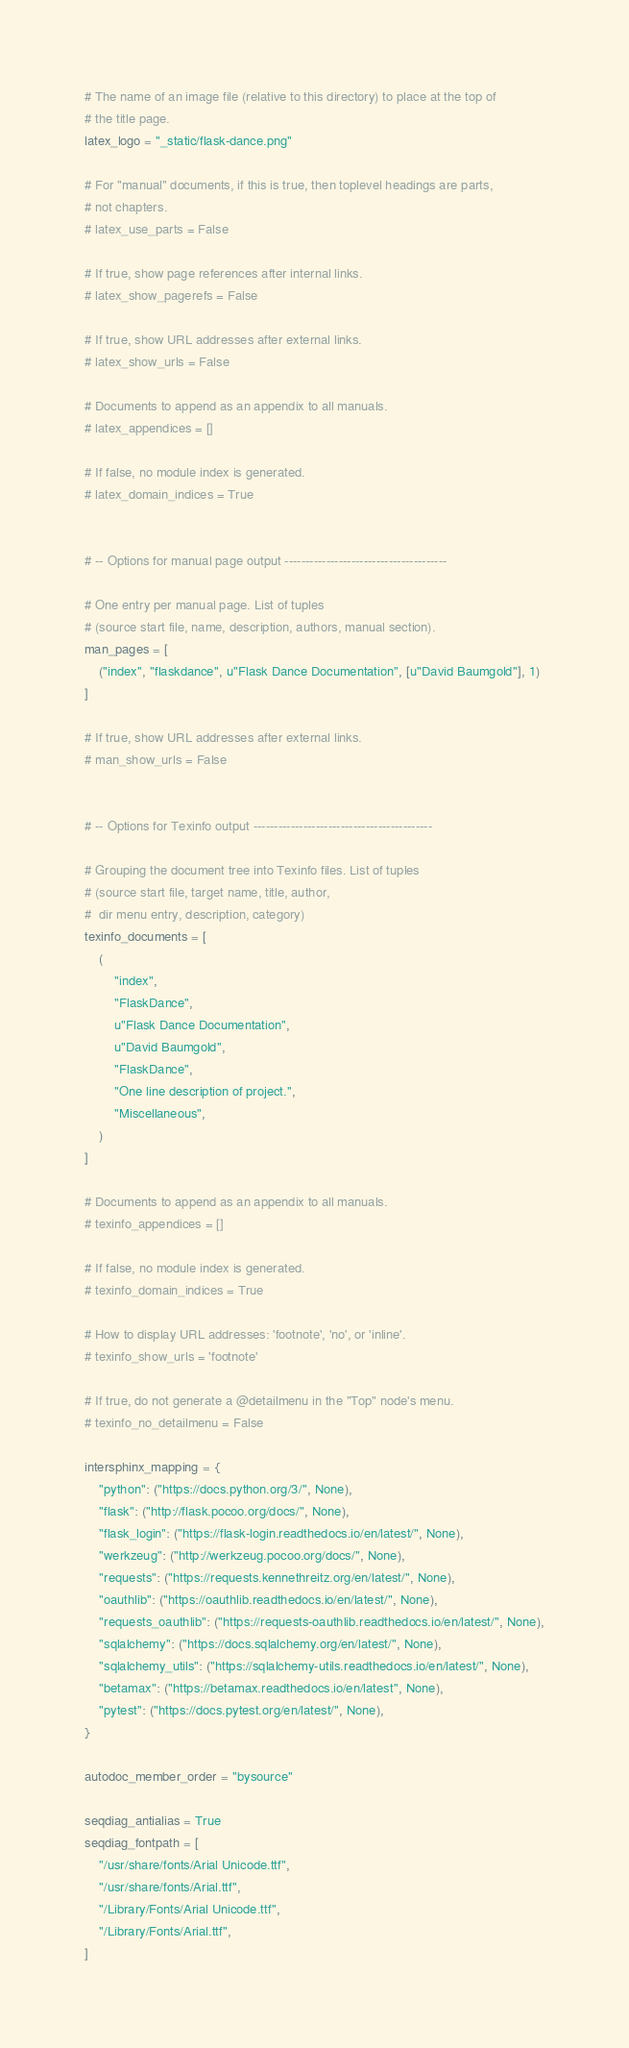<code> <loc_0><loc_0><loc_500><loc_500><_Python_># The name of an image file (relative to this directory) to place at the top of
# the title page.
latex_logo = "_static/flask-dance.png"

# For "manual" documents, if this is true, then toplevel headings are parts,
# not chapters.
# latex_use_parts = False

# If true, show page references after internal links.
# latex_show_pagerefs = False

# If true, show URL addresses after external links.
# latex_show_urls = False

# Documents to append as an appendix to all manuals.
# latex_appendices = []

# If false, no module index is generated.
# latex_domain_indices = True


# -- Options for manual page output ---------------------------------------

# One entry per manual page. List of tuples
# (source start file, name, description, authors, manual section).
man_pages = [
    ("index", "flaskdance", u"Flask Dance Documentation", [u"David Baumgold"], 1)
]

# If true, show URL addresses after external links.
# man_show_urls = False


# -- Options for Texinfo output -------------------------------------------

# Grouping the document tree into Texinfo files. List of tuples
# (source start file, target name, title, author,
#  dir menu entry, description, category)
texinfo_documents = [
    (
        "index",
        "FlaskDance",
        u"Flask Dance Documentation",
        u"David Baumgold",
        "FlaskDance",
        "One line description of project.",
        "Miscellaneous",
    )
]

# Documents to append as an appendix to all manuals.
# texinfo_appendices = []

# If false, no module index is generated.
# texinfo_domain_indices = True

# How to display URL addresses: 'footnote', 'no', or 'inline'.
# texinfo_show_urls = 'footnote'

# If true, do not generate a @detailmenu in the "Top" node's menu.
# texinfo_no_detailmenu = False

intersphinx_mapping = {
    "python": ("https://docs.python.org/3/", None),
    "flask": ("http://flask.pocoo.org/docs/", None),
    "flask_login": ("https://flask-login.readthedocs.io/en/latest/", None),
    "werkzeug": ("http://werkzeug.pocoo.org/docs/", None),
    "requests": ("https://requests.kennethreitz.org/en/latest/", None),
    "oauthlib": ("https://oauthlib.readthedocs.io/en/latest/", None),
    "requests_oauthlib": ("https://requests-oauthlib.readthedocs.io/en/latest/", None),
    "sqlalchemy": ("https://docs.sqlalchemy.org/en/latest/", None),
    "sqlalchemy_utils": ("https://sqlalchemy-utils.readthedocs.io/en/latest/", None),
    "betamax": ("https://betamax.readthedocs.io/en/latest", None),
    "pytest": ("https://docs.pytest.org/en/latest/", None),
}

autodoc_member_order = "bysource"

seqdiag_antialias = True
seqdiag_fontpath = [
    "/usr/share/fonts/Arial Unicode.ttf",
    "/usr/share/fonts/Arial.ttf",
    "/Library/Fonts/Arial Unicode.ttf",
    "/Library/Fonts/Arial.ttf",
]
</code> 